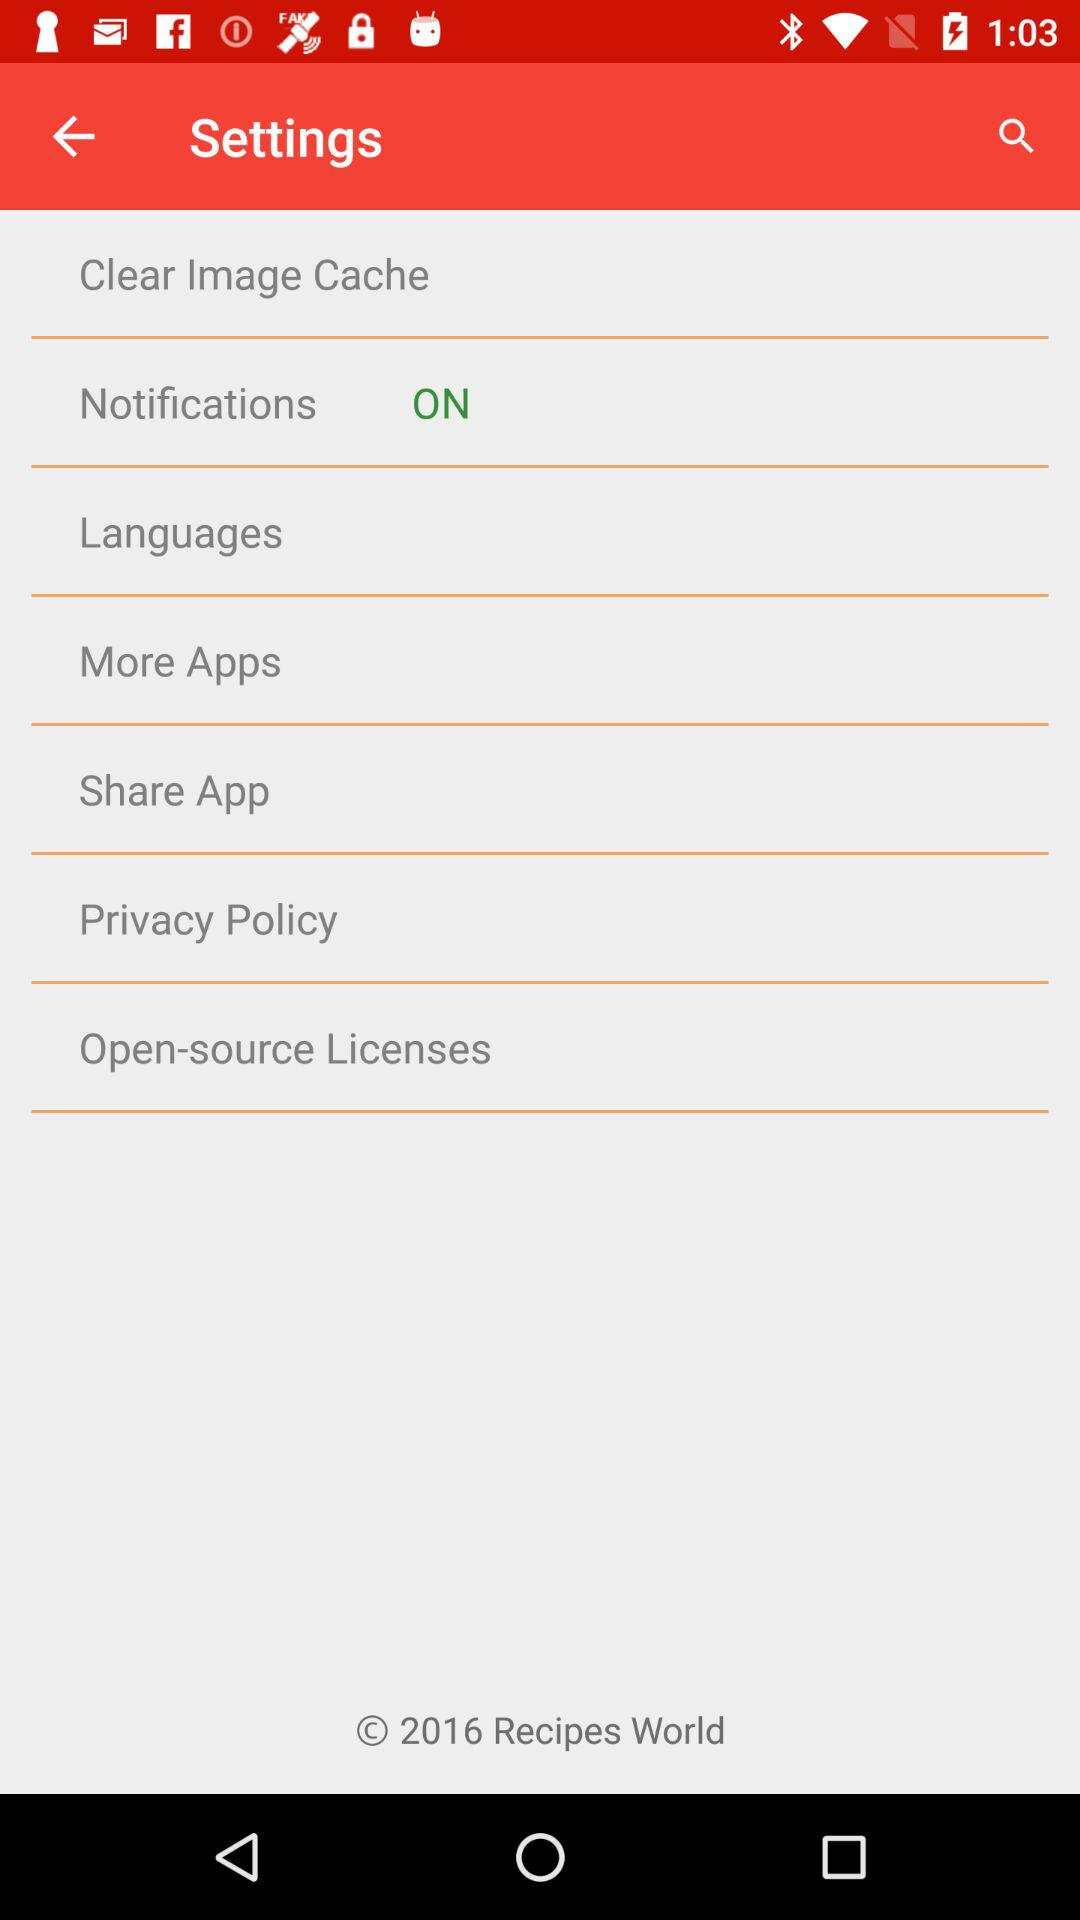What is the status of the "Notifications" setting? The status of the "Notifications" setting is "on". 